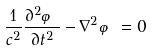Convert formula to latex. <formula><loc_0><loc_0><loc_500><loc_500>\frac { 1 } { c ^ { 2 } } \frac { \partial ^ { 2 } \varphi } { \partial t ^ { 2 } } - \nabla ^ { 2 } \varphi = 0</formula> 